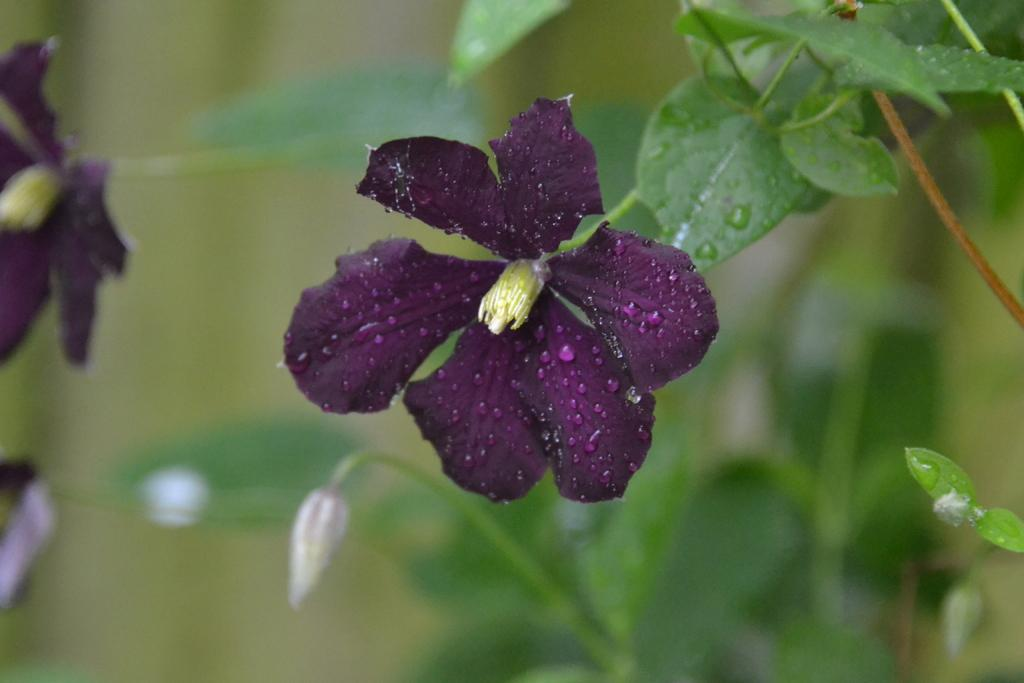What type of flower is present in the image? There is a pink flower in the image. What is the pink flower attached to? The pink flower is attached to a green plant. How would you describe the background of the image? The background of the image is blurry. What else can be seen in the background besides the blurry effect? There are flowers and plants visible in the background. How many dogs are playing with the partner in the image? There are no dogs or partners present in the image; it features a pink flower attached to a green plant with a blurry background. 